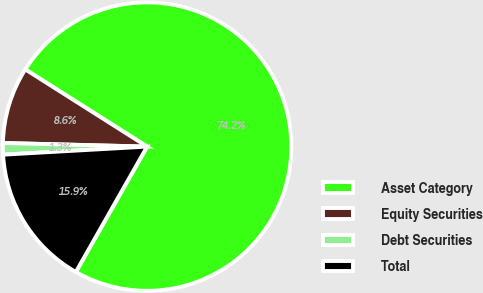Convert chart to OTSL. <chart><loc_0><loc_0><loc_500><loc_500><pie_chart><fcel>Asset Category<fcel>Equity Securities<fcel>Debt Securities<fcel>Total<nl><fcel>74.23%<fcel>8.59%<fcel>1.29%<fcel>15.88%<nl></chart> 